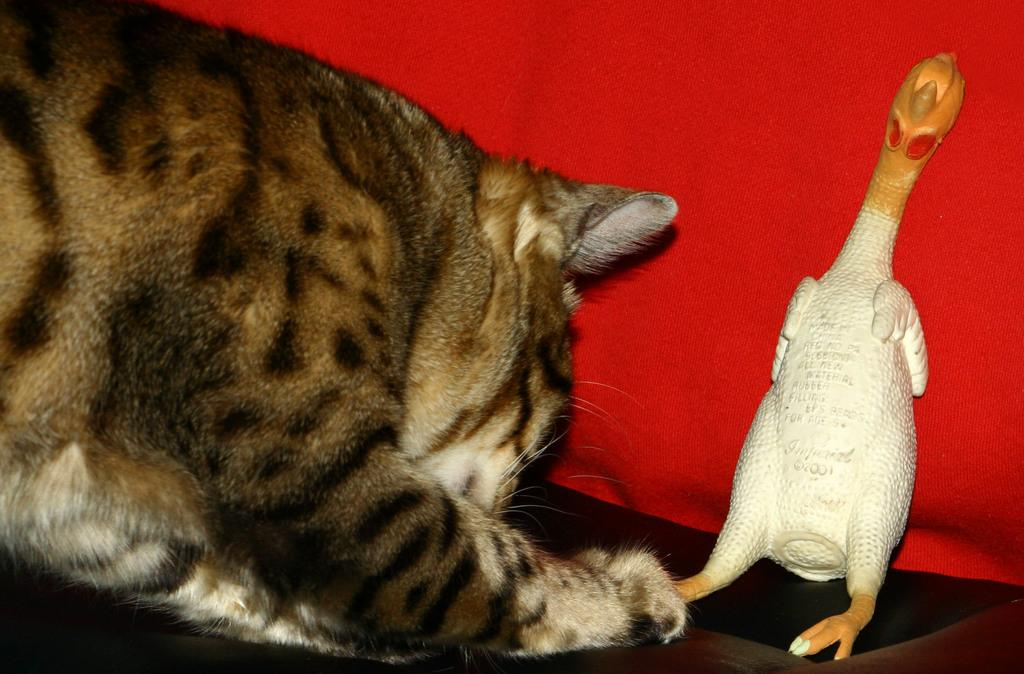What animal can be seen on the left side of the image? There is a cat on the left side of the image. What object can be seen on the right side of the image? There is a doll on the right side of the image. What color is the sheet in the background of the image? There is a red color sheet in the background of the image. What type of riddle can be seen being solved by the sheep in the image? There is no sheep or riddle present in the image. How many yams are visible in the image? There are no yams present in the image. 